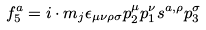<formula> <loc_0><loc_0><loc_500><loc_500>f _ { 5 } ^ { a } = i \cdot m _ { j } \epsilon _ { \mu \nu \rho \sigma } p _ { 2 } ^ { \mu } p _ { 1 } ^ { \nu } s ^ { a , \rho } p _ { 3 } ^ { \sigma }</formula> 